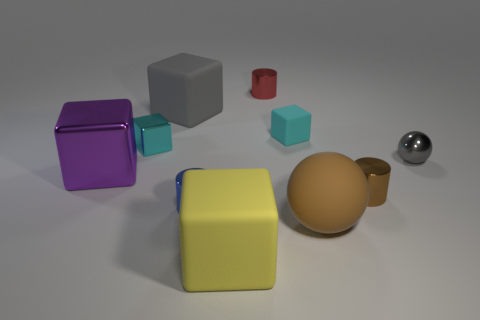There is a tiny cylinder that is behind the cyan block on the left side of the red cylinder; what is it made of?
Your response must be concise. Metal. Is the number of tiny brown metallic cylinders that are on the left side of the large yellow block greater than the number of big brown matte objects that are to the right of the gray shiny ball?
Keep it short and to the point. No. The purple metallic object has what size?
Provide a succinct answer. Large. There is a tiny cylinder that is behind the cyan rubber object; does it have the same color as the matte sphere?
Provide a succinct answer. No. Are there any other things that are the same shape as the tiny brown metal object?
Give a very brief answer. Yes. Are there any large rubber things right of the large thing that is on the right side of the red metallic object?
Keep it short and to the point. No. Is the number of yellow rubber blocks that are to the left of the small blue metal object less than the number of blocks that are behind the small cyan metal block?
Your response must be concise. Yes. There is a sphere that is behind the small metallic cylinder left of the small metal cylinder behind the brown cylinder; what size is it?
Keep it short and to the point. Small. There is a cyan cube on the right side of the cyan metallic block; is it the same size as the gray ball?
Your answer should be compact. Yes. What number of other things are there of the same material as the yellow object
Your answer should be very brief. 3. 